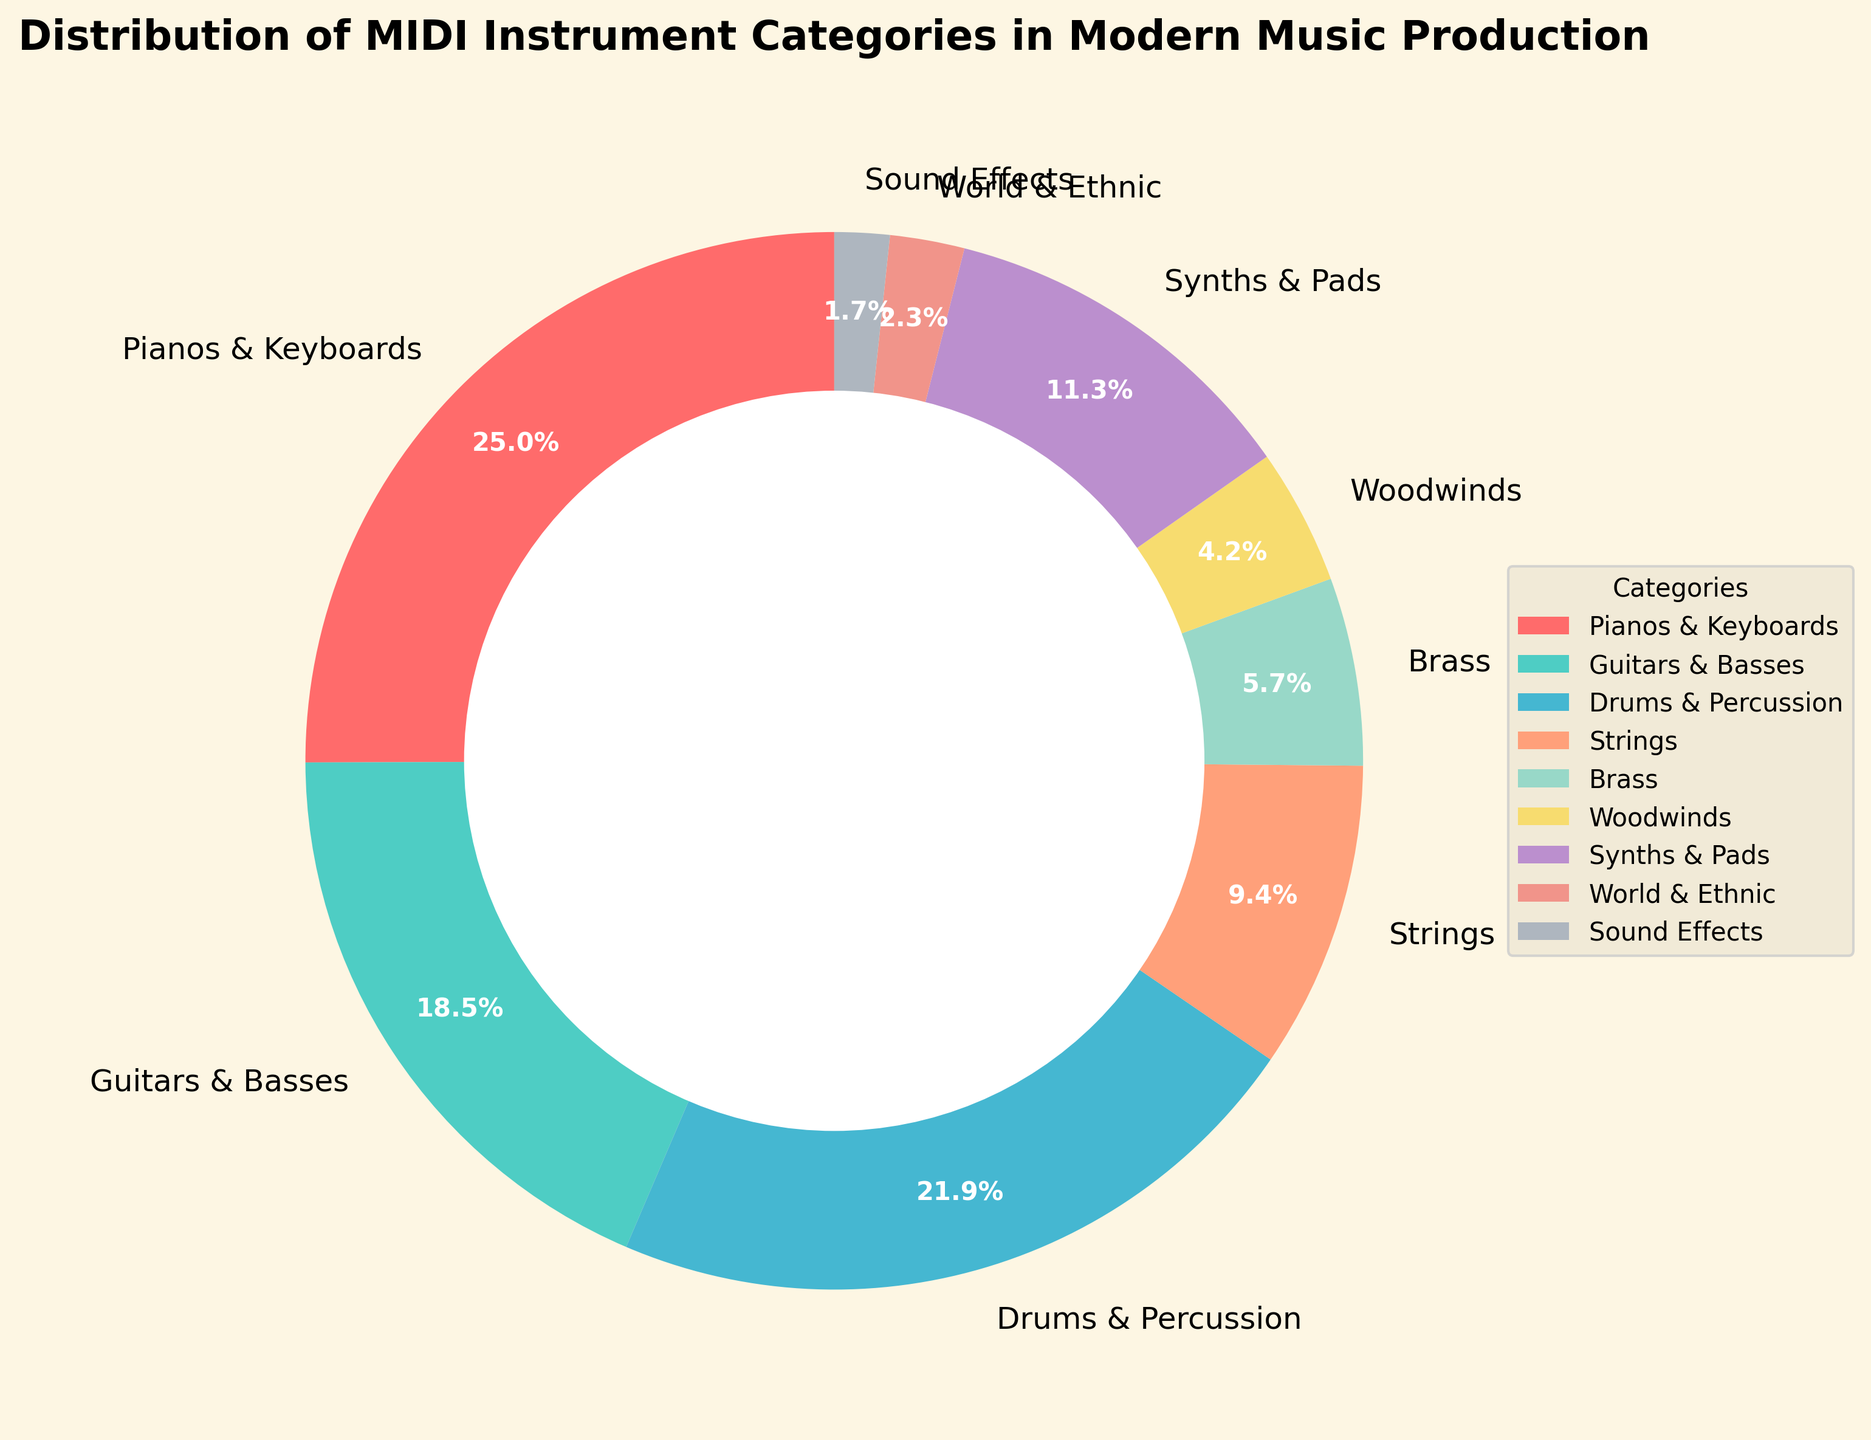What is the most common MIDI instrument category used in modern music production? The most common category can be identified by looking at the segment with the largest percentage in the pie chart. "Pianos & Keyboards" has the largest segment with 25.3%.
Answer: Pianos & Keyboards What is the total percentage of MIDI instruments that come under Strings and Brass categories combined? To find the total percentage for Strings and Brass, add their individual percentages: 9.5% (Strings) + 5.8% (Brass) = 15.3%.
Answer: 15.3% Which MIDI instrument category is used more: Drums & Percussion or Guitars & Basses? Compare the percentages of the two categories. Drums & Percussion has 22.1%, while Guitars & Basses has 18.7%. Drums & Percussion is higher.
Answer: Drums & Percussion What is the percentage difference between the least common MIDI instrument (Sound Effects) and the most common MIDI instrument (Pianos & Keyboards)? Subtract the percentage of the least common from the most common: 25.3% (Pianos & Keyboards) - 1.7% (Sound Effects) = 23.6%.
Answer: 23.6% What are the instrument categories that together make up more than 50% of the total distribution? Sum the percentages until it exceeds 50%. Starting from the most common: Pianos & Keyboards (25.3%) + Drums & Percussion (22.1%) = 47.4%. Adding Guitars & Basses (18.7%) takes the total to 66.1%, which exceeds 50%.
Answer: Pianos & Keyboards, Drums & Percussion, Guitars & Basses Which category is represented by the purple segment in the pie chart? Identify the purple segment by referring to the provided colors. The Strings category is displayed in purple.
Answer: Strings Between Synths & Pads and Woodwinds, which has a smaller percentage and by how much? Subtract the smaller percentage from the larger percentage between the two categories: 11.4% (Synths & Pads) - 4.2% (Woodwinds) = 7.2%.
Answer: Woodwinds, by 7.2% If you added the percentage of three smallest categories, would it surpass 10%? Check the three smallest categories: World & Ethnic (2.3%), Sound Effects (1.7%), and Woodwinds (4.2%). Their sum is 2.3% + 1.7% + 4.2% = 8.2%.
Answer: No 